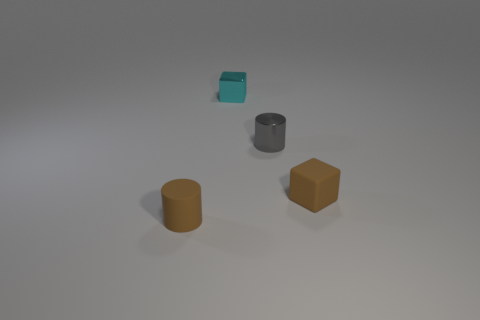Can you describe the shapes and their colors in this image? Certainly! The image shows four objects. There's a teal-colored cube and a grey cylinder positioned closer to the upper right side, while a brown cylinder and a brown cube are located towards the lower left side. Each pair of similarly shaped objects shares the same color. What could these objects represent in a symbolic sense? In a symbolic sense, the objects might represent diversity and unity. Despite the differences in shapes and colors, the objects are arranged in a balanced manner, symbolizing coexistence and harmony. Alternatively, they could symbolize building blocks of knowledge or components of a structured system. 